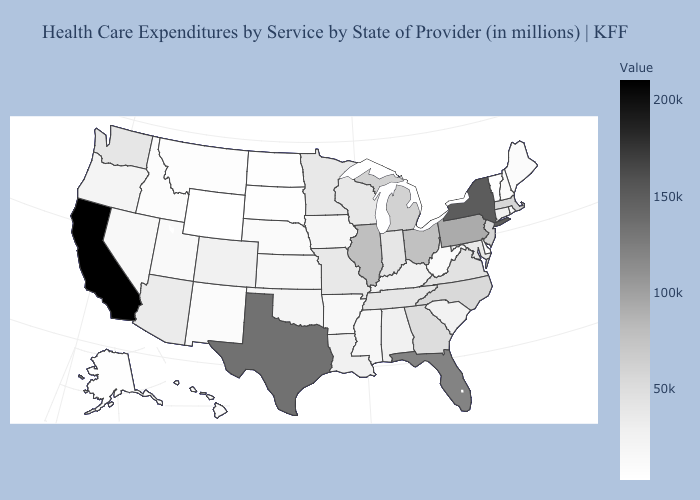Among the states that border Utah , does New Mexico have the lowest value?
Concise answer only. No. Does California have the highest value in the USA?
Keep it brief. Yes. Which states have the lowest value in the Northeast?
Short answer required. Vermont. Is the legend a continuous bar?
Quick response, please. Yes. Does Nebraska have the highest value in the MidWest?
Quick response, please. No. Is the legend a continuous bar?
Write a very short answer. Yes. 